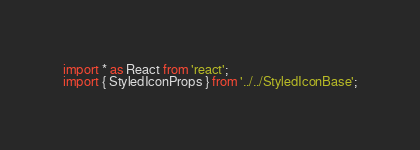<code> <loc_0><loc_0><loc_500><loc_500><_TypeScript_>import * as React from 'react';
import { StyledIconProps } from '../../StyledIconBase';</code> 